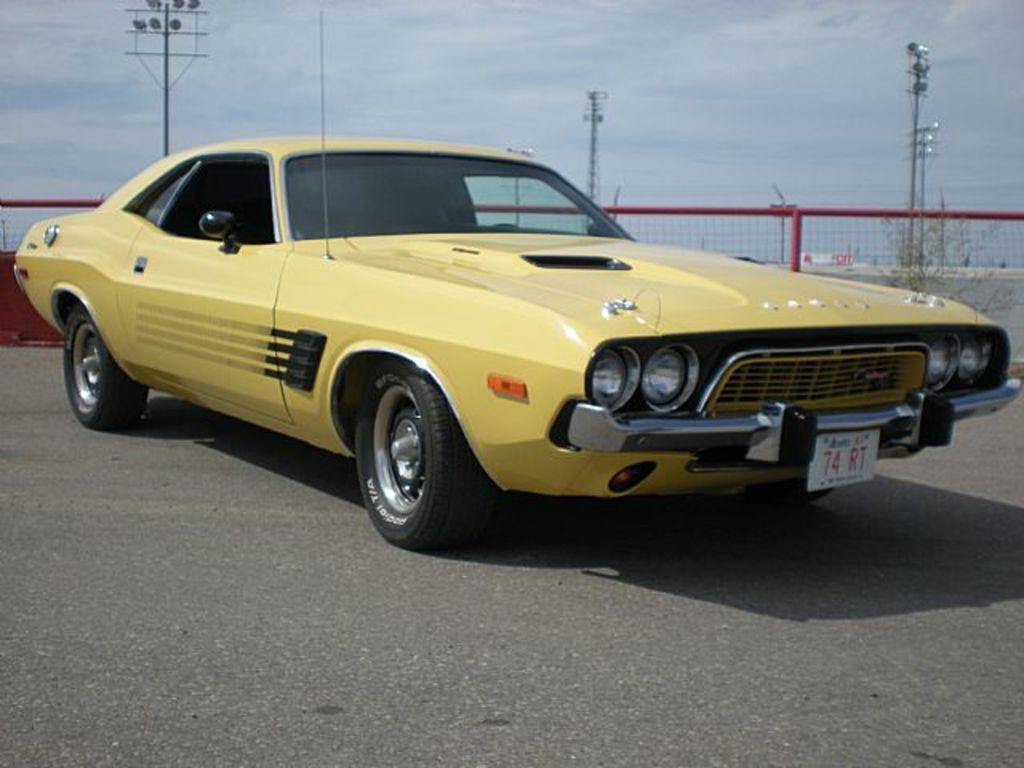What is the main subject of the image? There is a vehicle in the image. What is the setting of the image? There is a road in the image. What type of barrier is present in the image? There is fencing in the image. What can be seen on the ground in the image? The ground is visible in the image. What are the vertical structures in the image? There are poles in the image. What are the sources of illumination in the image? There are lights in the image. What tall structures are present in the image? There are towers in the image. What color object is on the left side of the image? There is a red color object on the left side of the image. What is visible in the background of the image? The sky is visible in the image. How does the vehicle smash the stick in the image? There is no stick present in the image, and the vehicle is not shown to be smashing anything. 